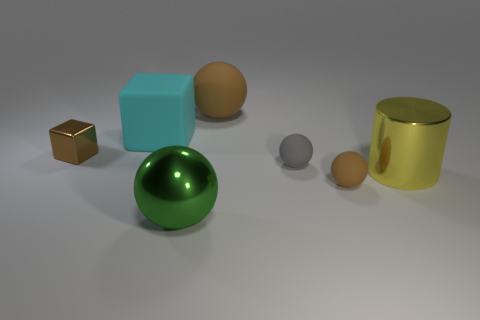Subtract 1 spheres. How many spheres are left? 3 Add 2 brown metallic objects. How many objects exist? 9 Subtract all yellow balls. Subtract all red cylinders. How many balls are left? 4 Subtract all blocks. How many objects are left? 5 Add 2 green matte cubes. How many green matte cubes exist? 2 Subtract 0 blue blocks. How many objects are left? 7 Subtract all large cyan rubber things. Subtract all large cyan matte things. How many objects are left? 5 Add 2 cyan blocks. How many cyan blocks are left? 3 